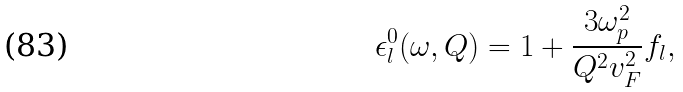Convert formula to latex. <formula><loc_0><loc_0><loc_500><loc_500>\epsilon _ { l } ^ { 0 } ( \omega , Q ) = 1 + \frac { 3 \omega _ { p } ^ { 2 } } { Q ^ { 2 } v _ { F } ^ { 2 } } f _ { l } ,</formula> 